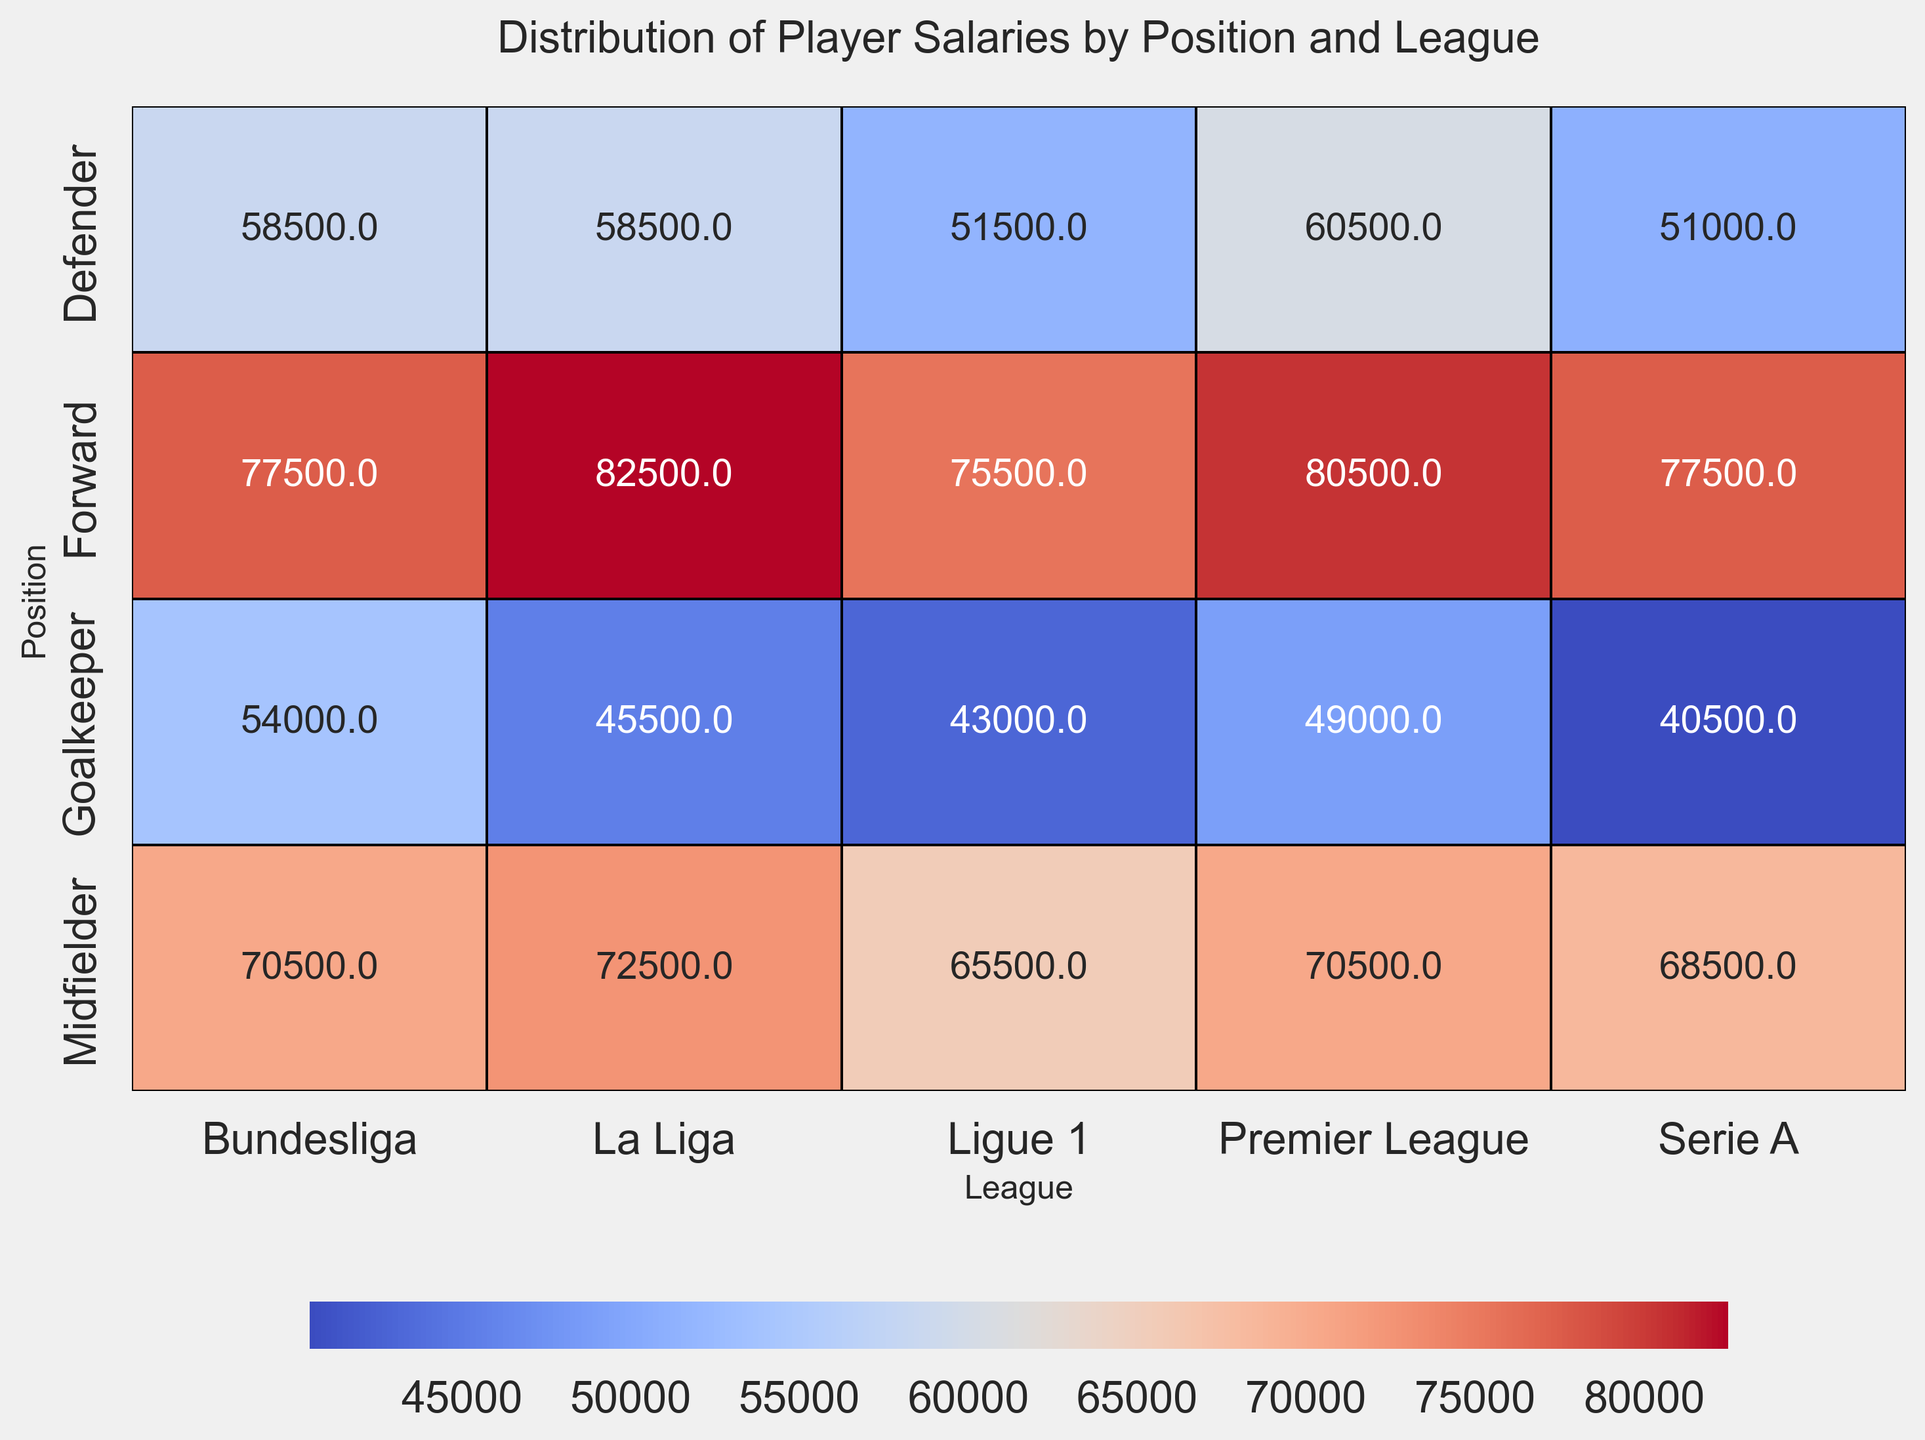Which league has the highest average salary for defenders? Look at the heatmap for the Defender row and identify the highest average salary among the leagues.
Answer: Premier League Which position in the La Liga has the lowest average salary? Check the La Liga column and compare the average salaries for all the positions (Goalkeeper, Defender, Midfielder, Forward) to find the lowest value.
Answer: Goalkeeper How much is the average salary difference between Midfielders in Serie A and Ligue 1? Find the average salaries of Midfielders in Serie A and Ligue 1 and compute the difference: 68,500 - 65,750.
Answer: 2,750 Which position and league combination has the highest average salary? Scan through all the values in the heatmap and identify the highest average salary, noting the corresponding position and league.
Answer: Forward, La Liga What is the average salary of Goalkeepers in Bundesliga? Locate the intersection of Goalkeeper row and Bundesliga column and read the average salary value.
Answer: 54,000 Which league shows the smallest difference between the average salaries of Goalkeepers and Forwards? Calculate the difference for each league and find the smallest among them: Premier League (49,000), La Liga (38,000), Serie A (37,000), Bundesliga (25,000), Ligue 1 (33,000).
Answer: Bundesliga Compare the average salaries of Midfielders in Premier League and La Liga; which one is higher and by how much? Compare the given average salaries for Midfielders in the Premier League and La Liga: La Liga - Premier League = 72,500 - 70,500
Answer: La Liga by 2,000 What visual color represents the highest average salary in the heatmap, and which combination does it belong to? Identify the darkest shade of red in the heatmap and check which positional and league combination it belongs to.
Answer: Dark red, Forward in La Liga How does the average salary of Defenders in Serie A compare to those in Bundesliga? Look at the heatmap values for Defenders in Serie A and Bundesliga and determine which one is higher or if they are equal.
Answer: Bundesliga is higher Which color gradient represents the average salary range in the heatmap, and what does it indicate about the salary distribution? Describe the color gradient used in the heatmap and explain how it corresponds to the range of salaries depicted.
Answer: The gradient ranges from blue (lower salaries) to red (higher salaries), indicating variation in salaries across positions and leagues 